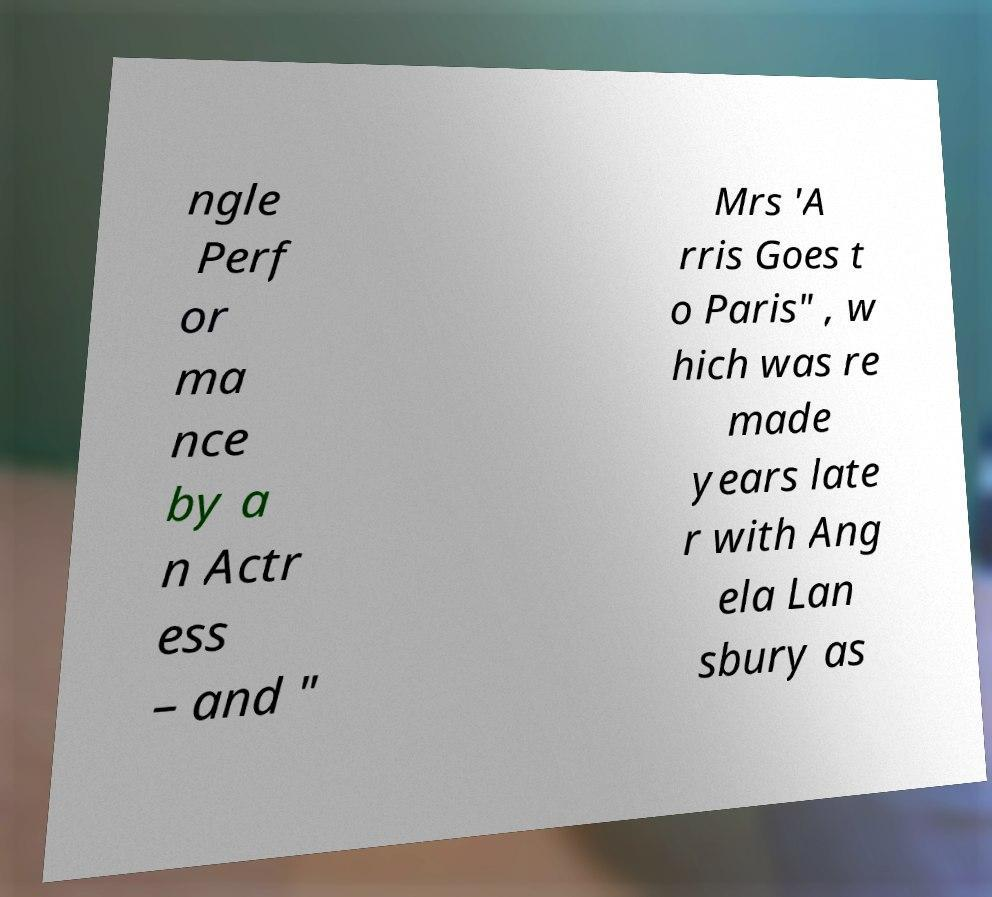Could you extract and type out the text from this image? ngle Perf or ma nce by a n Actr ess – and " Mrs 'A rris Goes t o Paris" , w hich was re made years late r with Ang ela Lan sbury as 